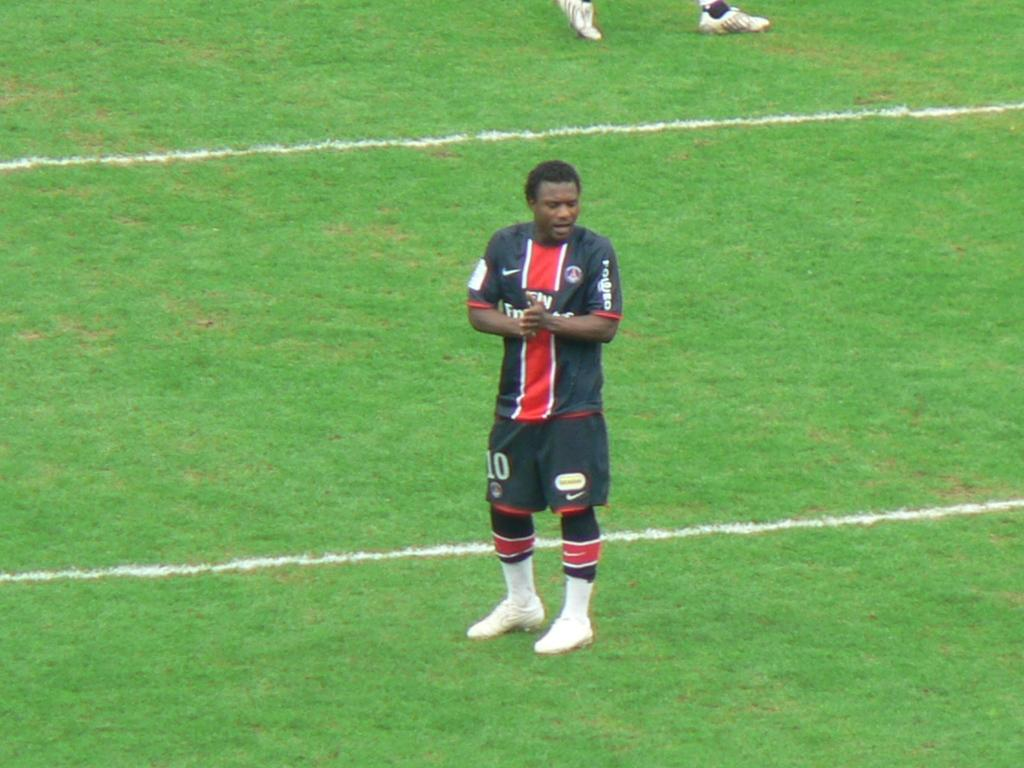<image>
Write a terse but informative summary of the picture. Soccer player number 10 stands on the field. 